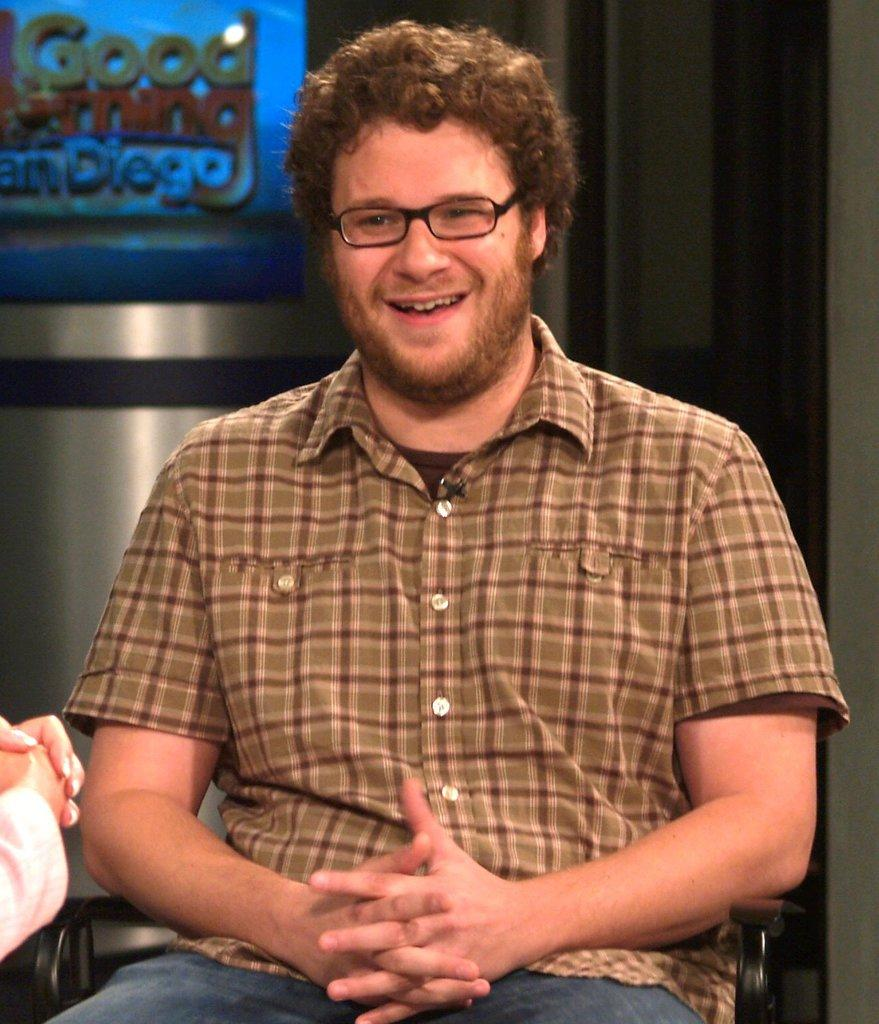What is the person in the image doing? The person is sitting on a chair in the image. What can be seen in the background of the image? There is a screen and a wall in the background of the image. How many bushes are visible in the image? There are no bushes present in the image. What type of thumb can be seen in the image? There is no thumb visible in the image. 